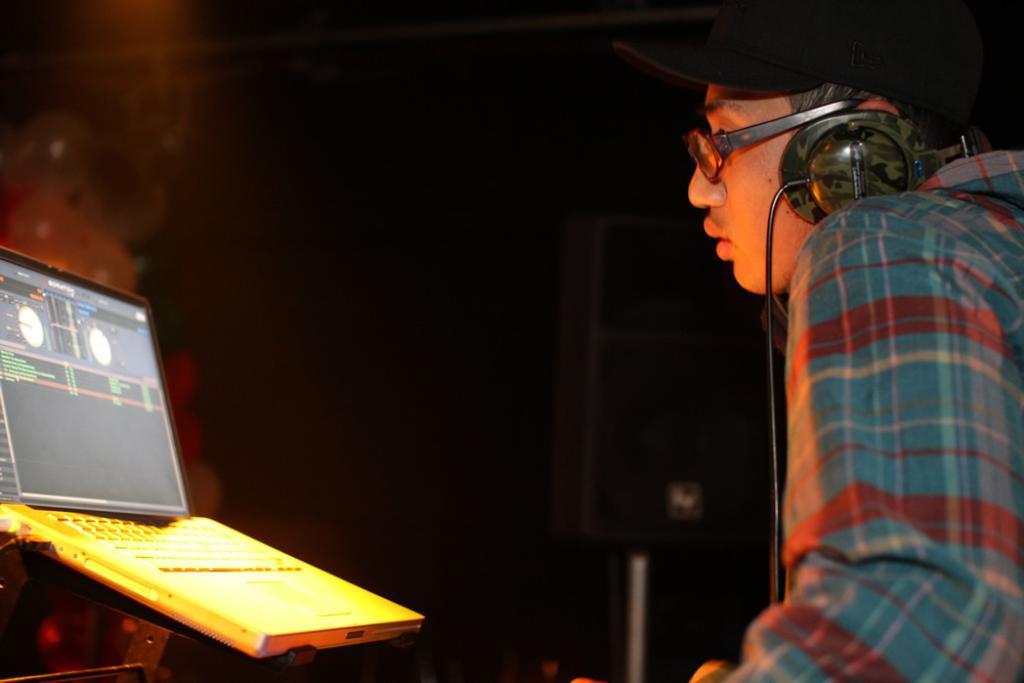Can you describe this image briefly? In this image we can see a person wearing cap, specs and headset on the right side. In front of him there is a laptop on the stand. In the back there is a speaker with a pole. In the background it is dark. 